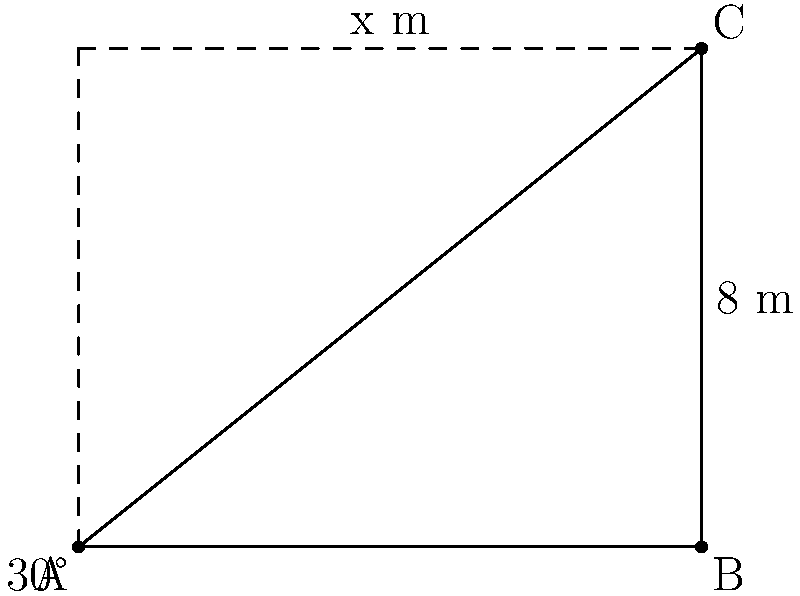As a trendsetter in the world of avant-garde hairstyling, you've created a triangular hair sculpture for a high-profile fashion show. The base of the sculpture is 10 meters wide, and it leans at a 30° angle from the vertical. If the slanted side of the sculpture is 8 meters long, what is the height (x) of your masterpiece? Round your answer to the nearest tenth of a meter. Let's approach this step-by-step:

1) First, let's identify what we know:
   - The base of the triangle is 10 meters
   - The angle between the vertical and the slanted side is 30°
   - The slanted side (hypotenuse) is 8 meters

2) We need to find the height of the triangle, which is the side adjacent to the 30° angle in a right triangle.

3) We can use the cosine function to find this. Recall that:
   
   $\cos \theta = \frac{\text{adjacent}}{\text{hypotenuse}}$

4) In our case:
   
   $\cos 30° = \frac{x}{8}$

5) We know that $\cos 30° = \frac{\sqrt{3}}{2}$, so:

   $\frac{\sqrt{3}}{2} = \frac{x}{8}$

6) Solving for x:
   
   $x = 8 \cdot \frac{\sqrt{3}}{2} = 4\sqrt{3}$

7) To calculate this:
   
   $4\sqrt{3} \approx 4 \cdot 1.732 \approx 6.928$

8) Rounding to the nearest tenth:
   
   $x \approx 6.9$ meters
Answer: 6.9 m 